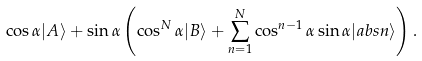<formula> <loc_0><loc_0><loc_500><loc_500>\cos \alpha | A \rangle + \sin \alpha \left ( \cos ^ { N } \alpha | B \rangle + \sum _ { n = 1 } ^ { N } \cos ^ { n - 1 } \alpha \sin \alpha | a b s n \rangle \right ) .</formula> 